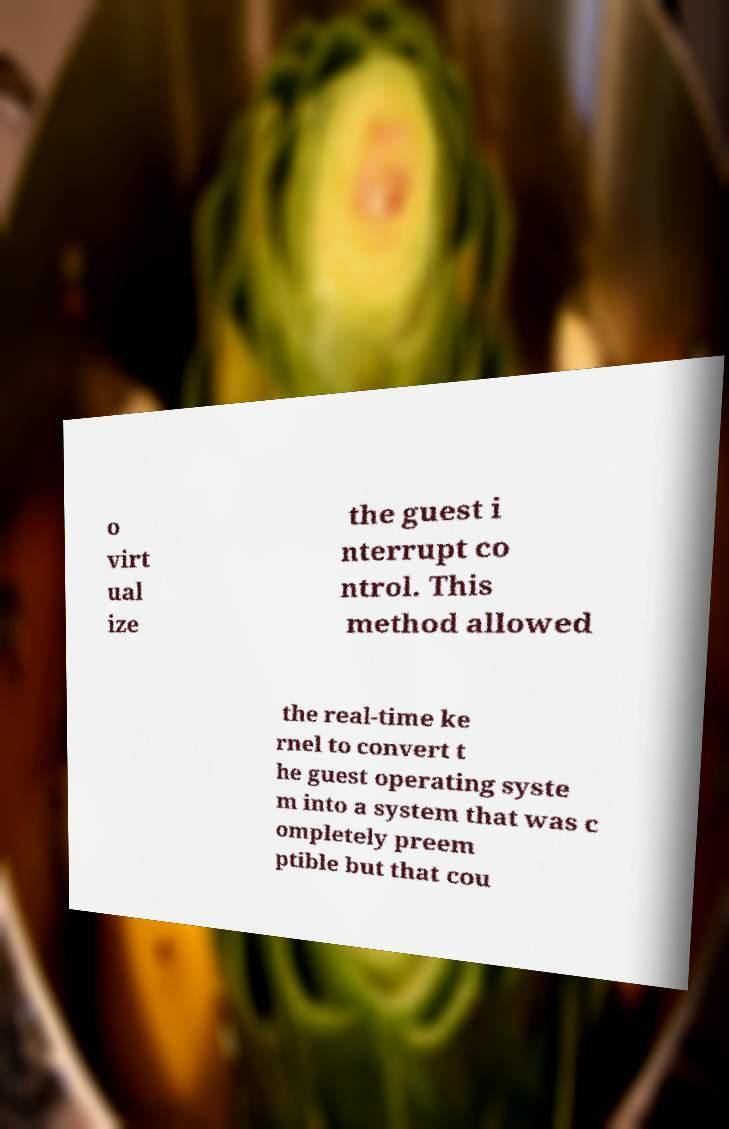Please read and relay the text visible in this image. What does it say? o virt ual ize the guest i nterrupt co ntrol. This method allowed the real-time ke rnel to convert t he guest operating syste m into a system that was c ompletely preem ptible but that cou 